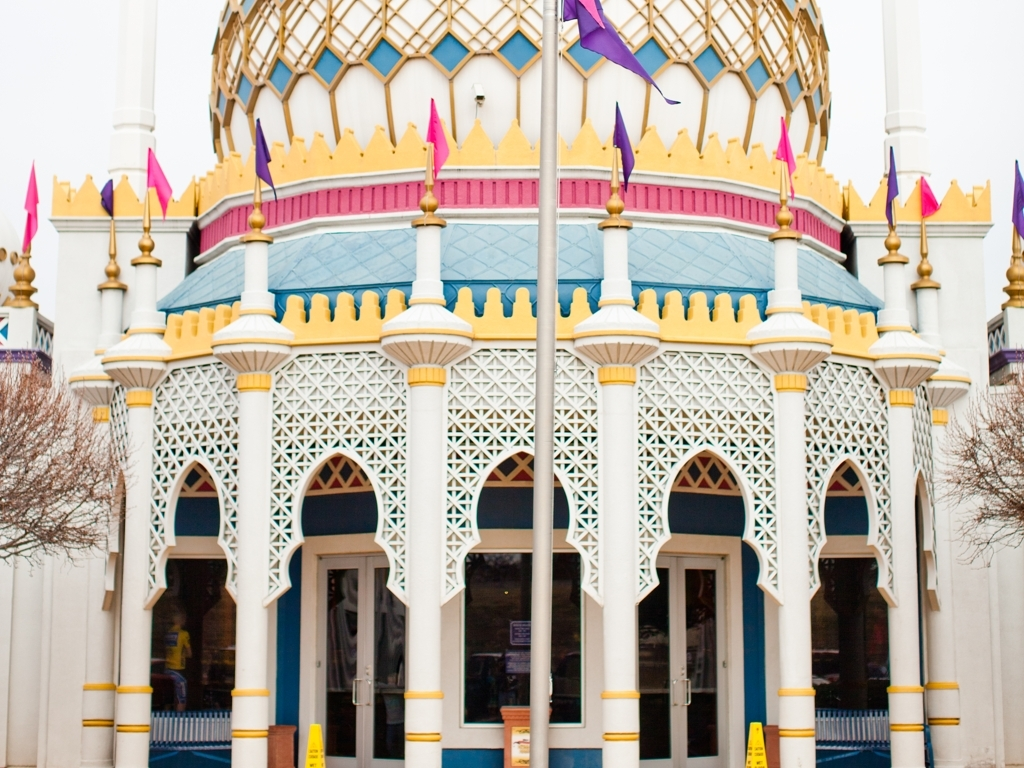What architectural style is featured in this building? This building showcases elements typical of Moorish Revival architecture, characterized by its elaborate geometric patterns, horseshoe arches, and vibrant colors. 